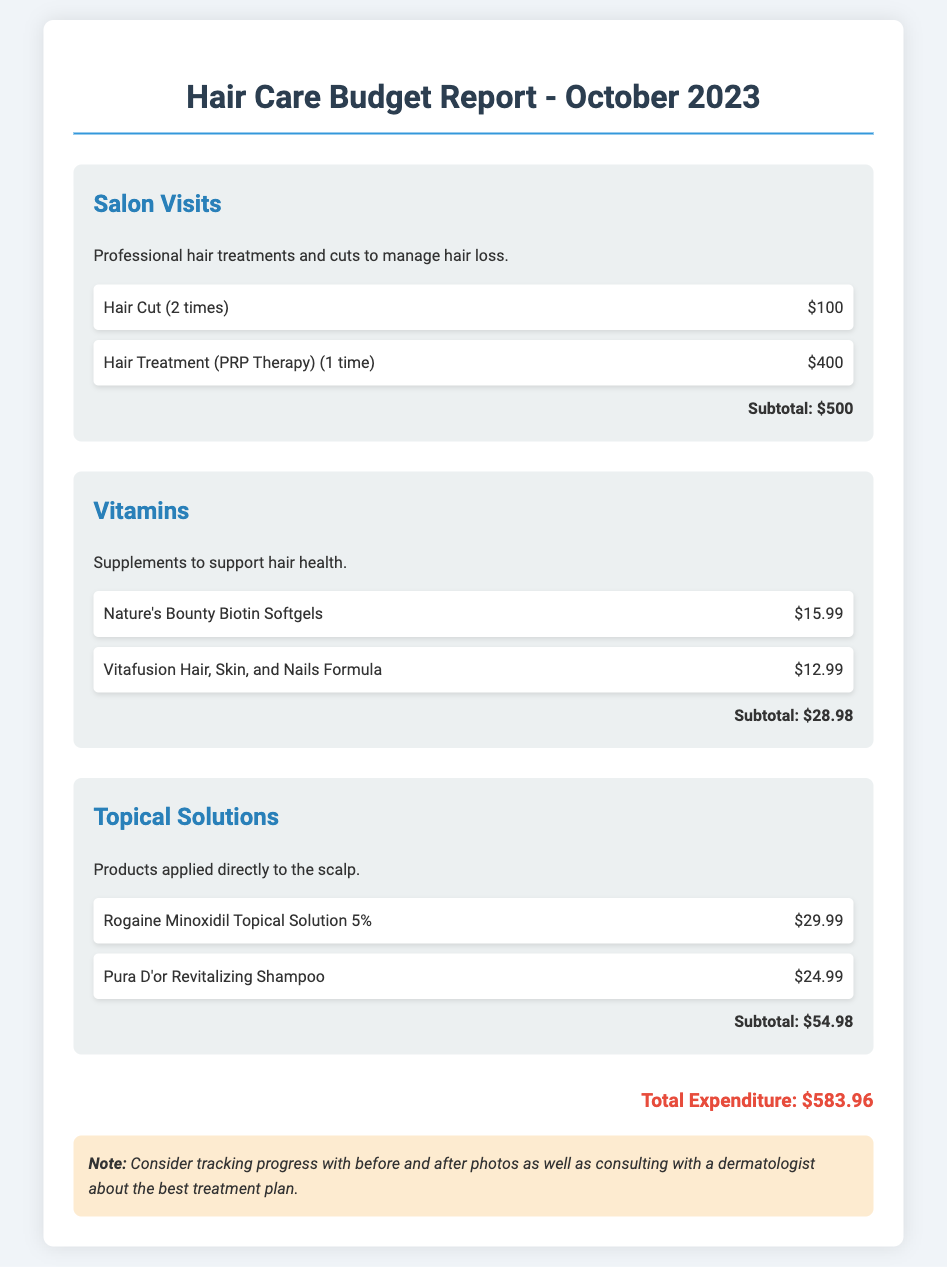What is the total expenditure? The total expenditure is the sum of all costs listed in the document, which adds up to $583.96.
Answer: $583.96 How many times was a hair cut received? The document specifies that hair cuts were received 2 times.
Answer: 2 times What is the cost of PRP Therapy? The cost of the Hair Treatment (PRP Therapy) is provided as $400.
Answer: $400 Which topical solution is mentioned first? The first topical solution listed in the document is Rogaine Minoxidil Topical Solution 5%.
Answer: Rogaine Minoxidil Topical Solution 5% What is the subtotal for vitamins? The subtotal for vitamins is calculated from the individual item costs, which total $28.98.
Answer: $28.98 How many items are listed under Salon Visits? There are 2 items listed under the Salon Visits section.
Answer: 2 What is the cost of Vitafusion Hair, Skin, and Nails Formula? The document states that the cost of Vitafusion Hair, Skin, and Nails Formula is $12.99.
Answer: $12.99 What additional recommendation is made in the notes section? The note recommends tracking progress with before and after photos and consulting a dermatologist.
Answer: Tracking progress with photos and consulting a dermatologist 